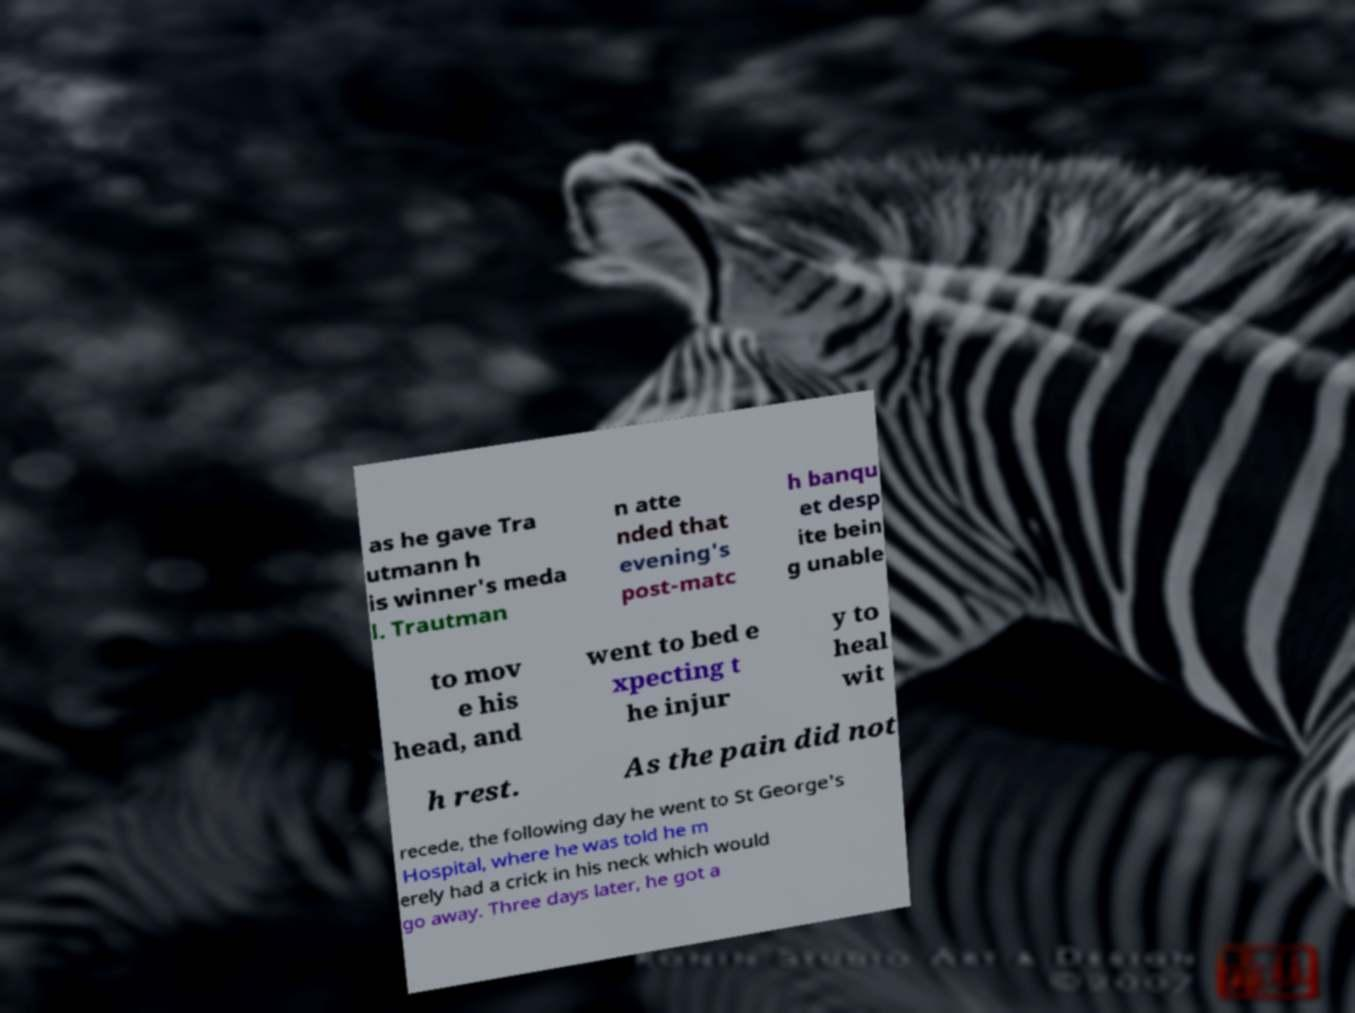For documentation purposes, I need the text within this image transcribed. Could you provide that? as he gave Tra utmann h is winner's meda l. Trautman n atte nded that evening's post-matc h banqu et desp ite bein g unable to mov e his head, and went to bed e xpecting t he injur y to heal wit h rest. As the pain did not recede, the following day he went to St George's Hospital, where he was told he m erely had a crick in his neck which would go away. Three days later, he got a 